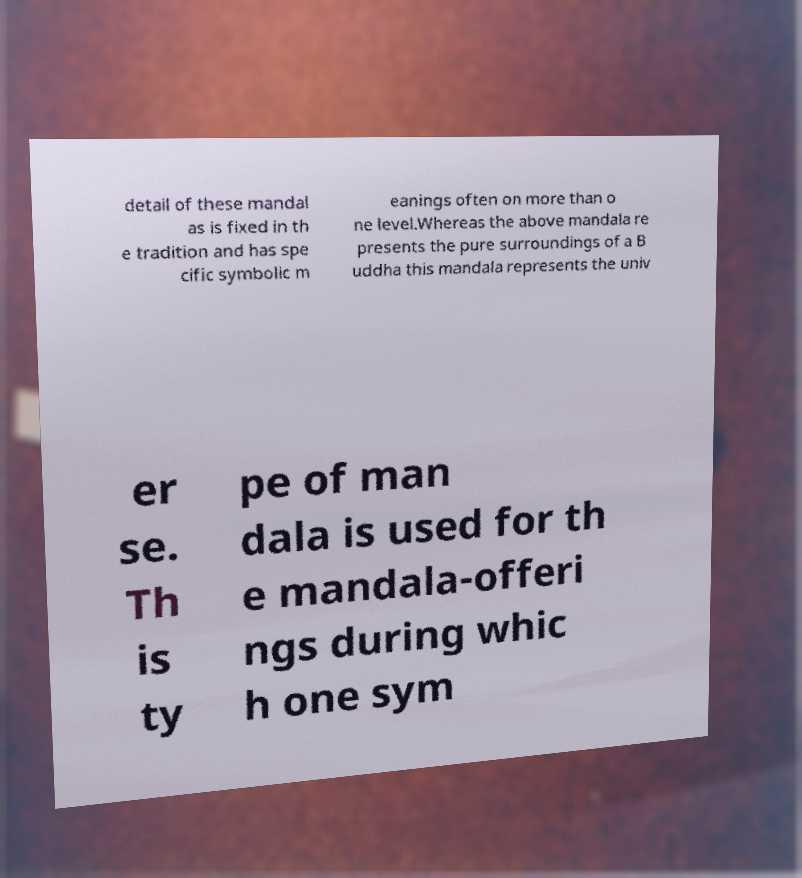Please read and relay the text visible in this image. What does it say? detail of these mandal as is fixed in th e tradition and has spe cific symbolic m eanings often on more than o ne level.Whereas the above mandala re presents the pure surroundings of a B uddha this mandala represents the univ er se. Th is ty pe of man dala is used for th e mandala-offeri ngs during whic h one sym 